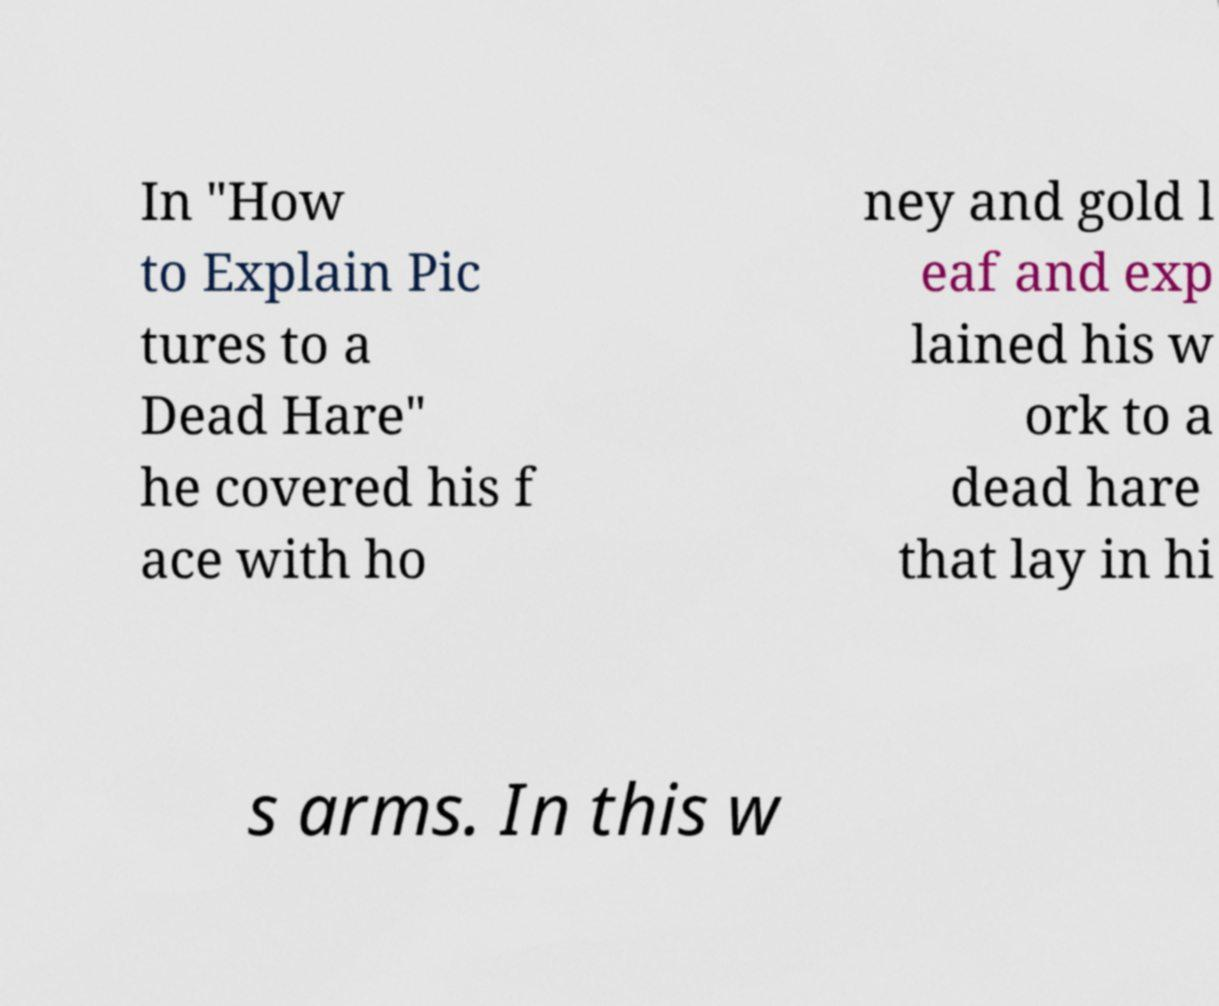Can you accurately transcribe the text from the provided image for me? In "How to Explain Pic tures to a Dead Hare" he covered his f ace with ho ney and gold l eaf and exp lained his w ork to a dead hare that lay in hi s arms. In this w 